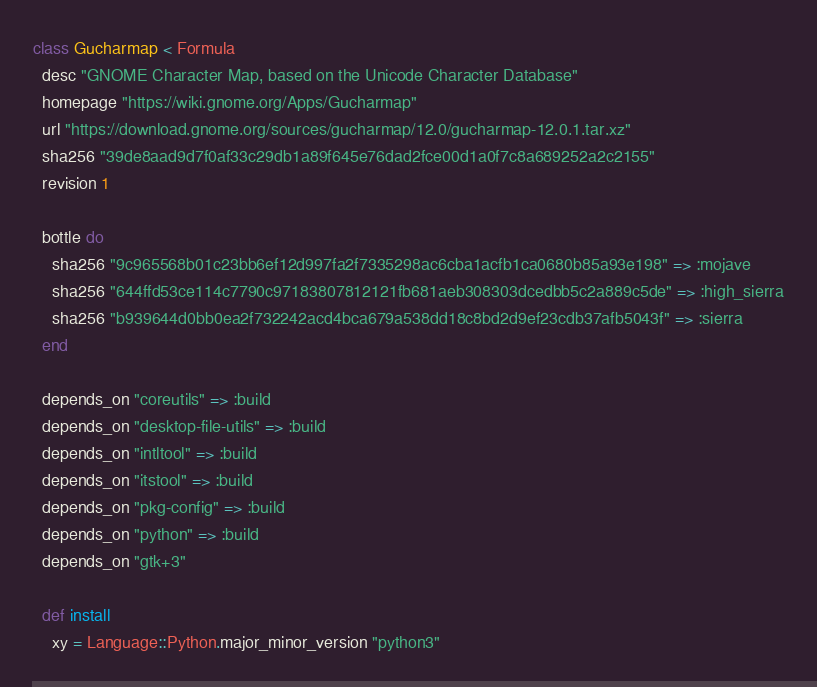Convert code to text. <code><loc_0><loc_0><loc_500><loc_500><_Ruby_>class Gucharmap < Formula
  desc "GNOME Character Map, based on the Unicode Character Database"
  homepage "https://wiki.gnome.org/Apps/Gucharmap"
  url "https://download.gnome.org/sources/gucharmap/12.0/gucharmap-12.0.1.tar.xz"
  sha256 "39de8aad9d7f0af33c29db1a89f645e76dad2fce00d1a0f7c8a689252a2c2155"
  revision 1

  bottle do
    sha256 "9c965568b01c23bb6ef12d997fa2f7335298ac6cba1acfb1ca0680b85a93e198" => :mojave
    sha256 "644ffd53ce114c7790c97183807812121fb681aeb308303dcedbb5c2a889c5de" => :high_sierra
    sha256 "b939644d0bb0ea2f732242acd4bca679a538dd18c8bd2d9ef23cdb37afb5043f" => :sierra
  end

  depends_on "coreutils" => :build
  depends_on "desktop-file-utils" => :build
  depends_on "intltool" => :build
  depends_on "itstool" => :build
  depends_on "pkg-config" => :build
  depends_on "python" => :build
  depends_on "gtk+3"

  def install
    xy = Language::Python.major_minor_version "python3"</code> 